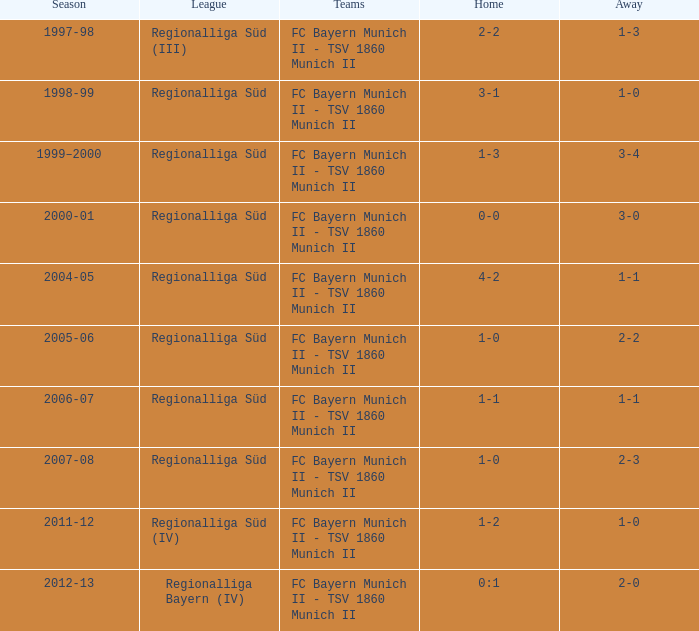What is the league with a 0:1 home? Regionalliga Bayern (IV). 